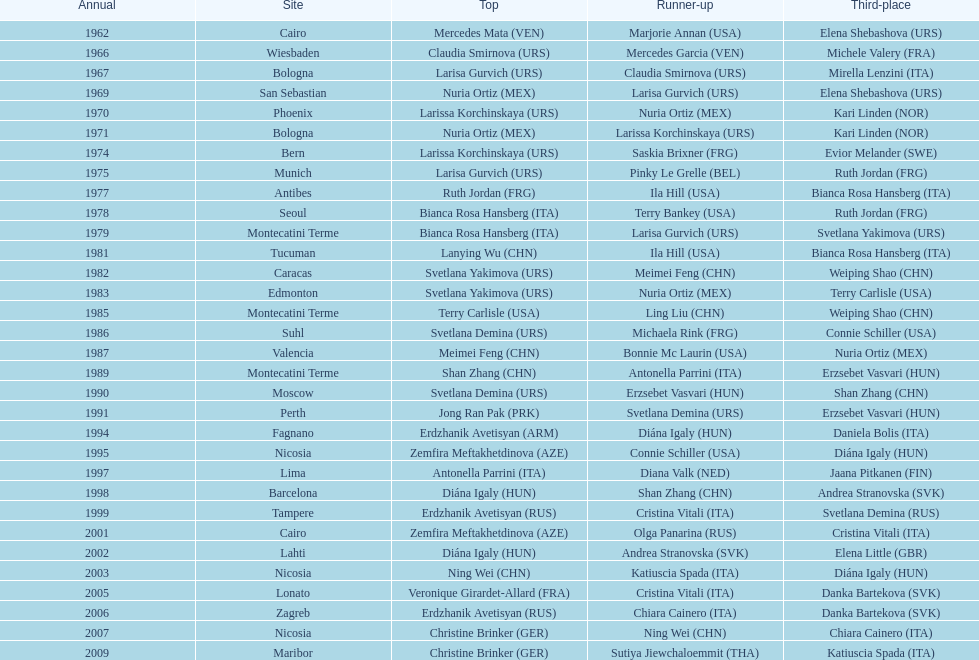Which country has won more gold medals: china or mexico? China. 